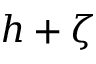<formula> <loc_0><loc_0><loc_500><loc_500>h + \zeta</formula> 